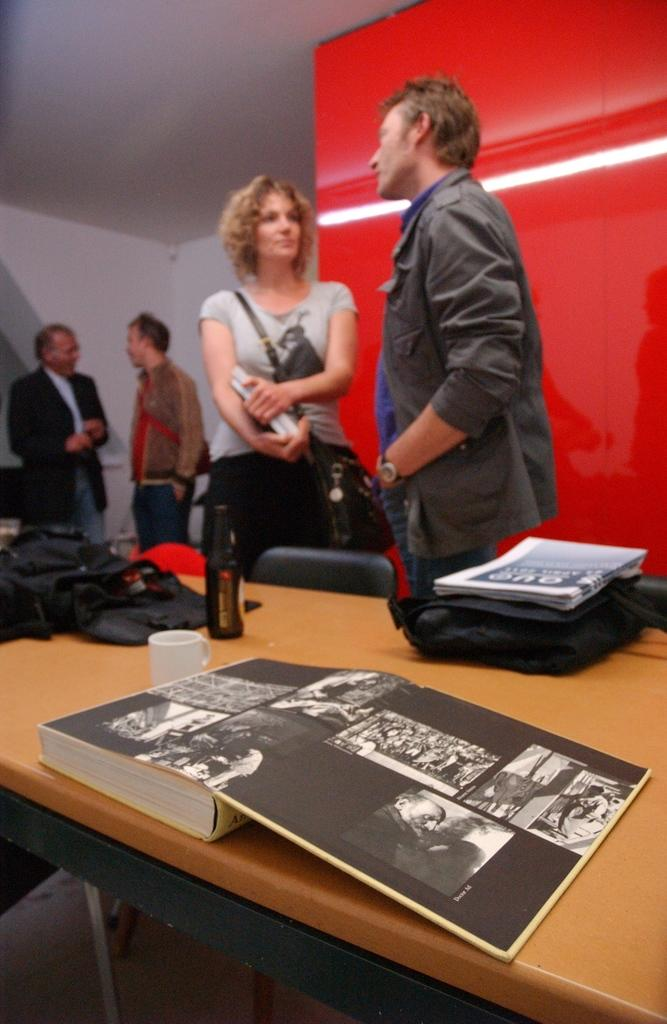Who is present in the image? There is a man and a woman in the image. What are the man and woman doing? The man and woman are talking to each other. Are there any other people in the image? Yes, there are two men at a distance in the image. What are the two men doing? The two men are talking to each other. What type of kite is the woman flying in the image? There is no kite present in the image; the woman is talking to the man. What season is depicted in the image, given the presence of spring flowers? There is no mention of spring flowers or any seasonal elements in the image. 